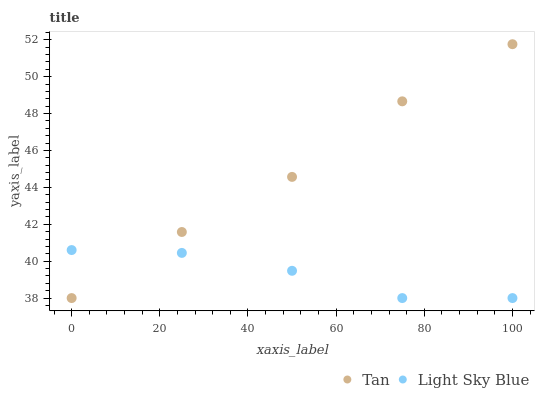Does Light Sky Blue have the minimum area under the curve?
Answer yes or no. Yes. Does Tan have the maximum area under the curve?
Answer yes or no. Yes. Does Light Sky Blue have the maximum area under the curve?
Answer yes or no. No. Is Tan the smoothest?
Answer yes or no. Yes. Is Light Sky Blue the roughest?
Answer yes or no. Yes. Is Light Sky Blue the smoothest?
Answer yes or no. No. Does Tan have the lowest value?
Answer yes or no. Yes. Does Tan have the highest value?
Answer yes or no. Yes. Does Light Sky Blue have the highest value?
Answer yes or no. No. Does Tan intersect Light Sky Blue?
Answer yes or no. Yes. Is Tan less than Light Sky Blue?
Answer yes or no. No. Is Tan greater than Light Sky Blue?
Answer yes or no. No. 